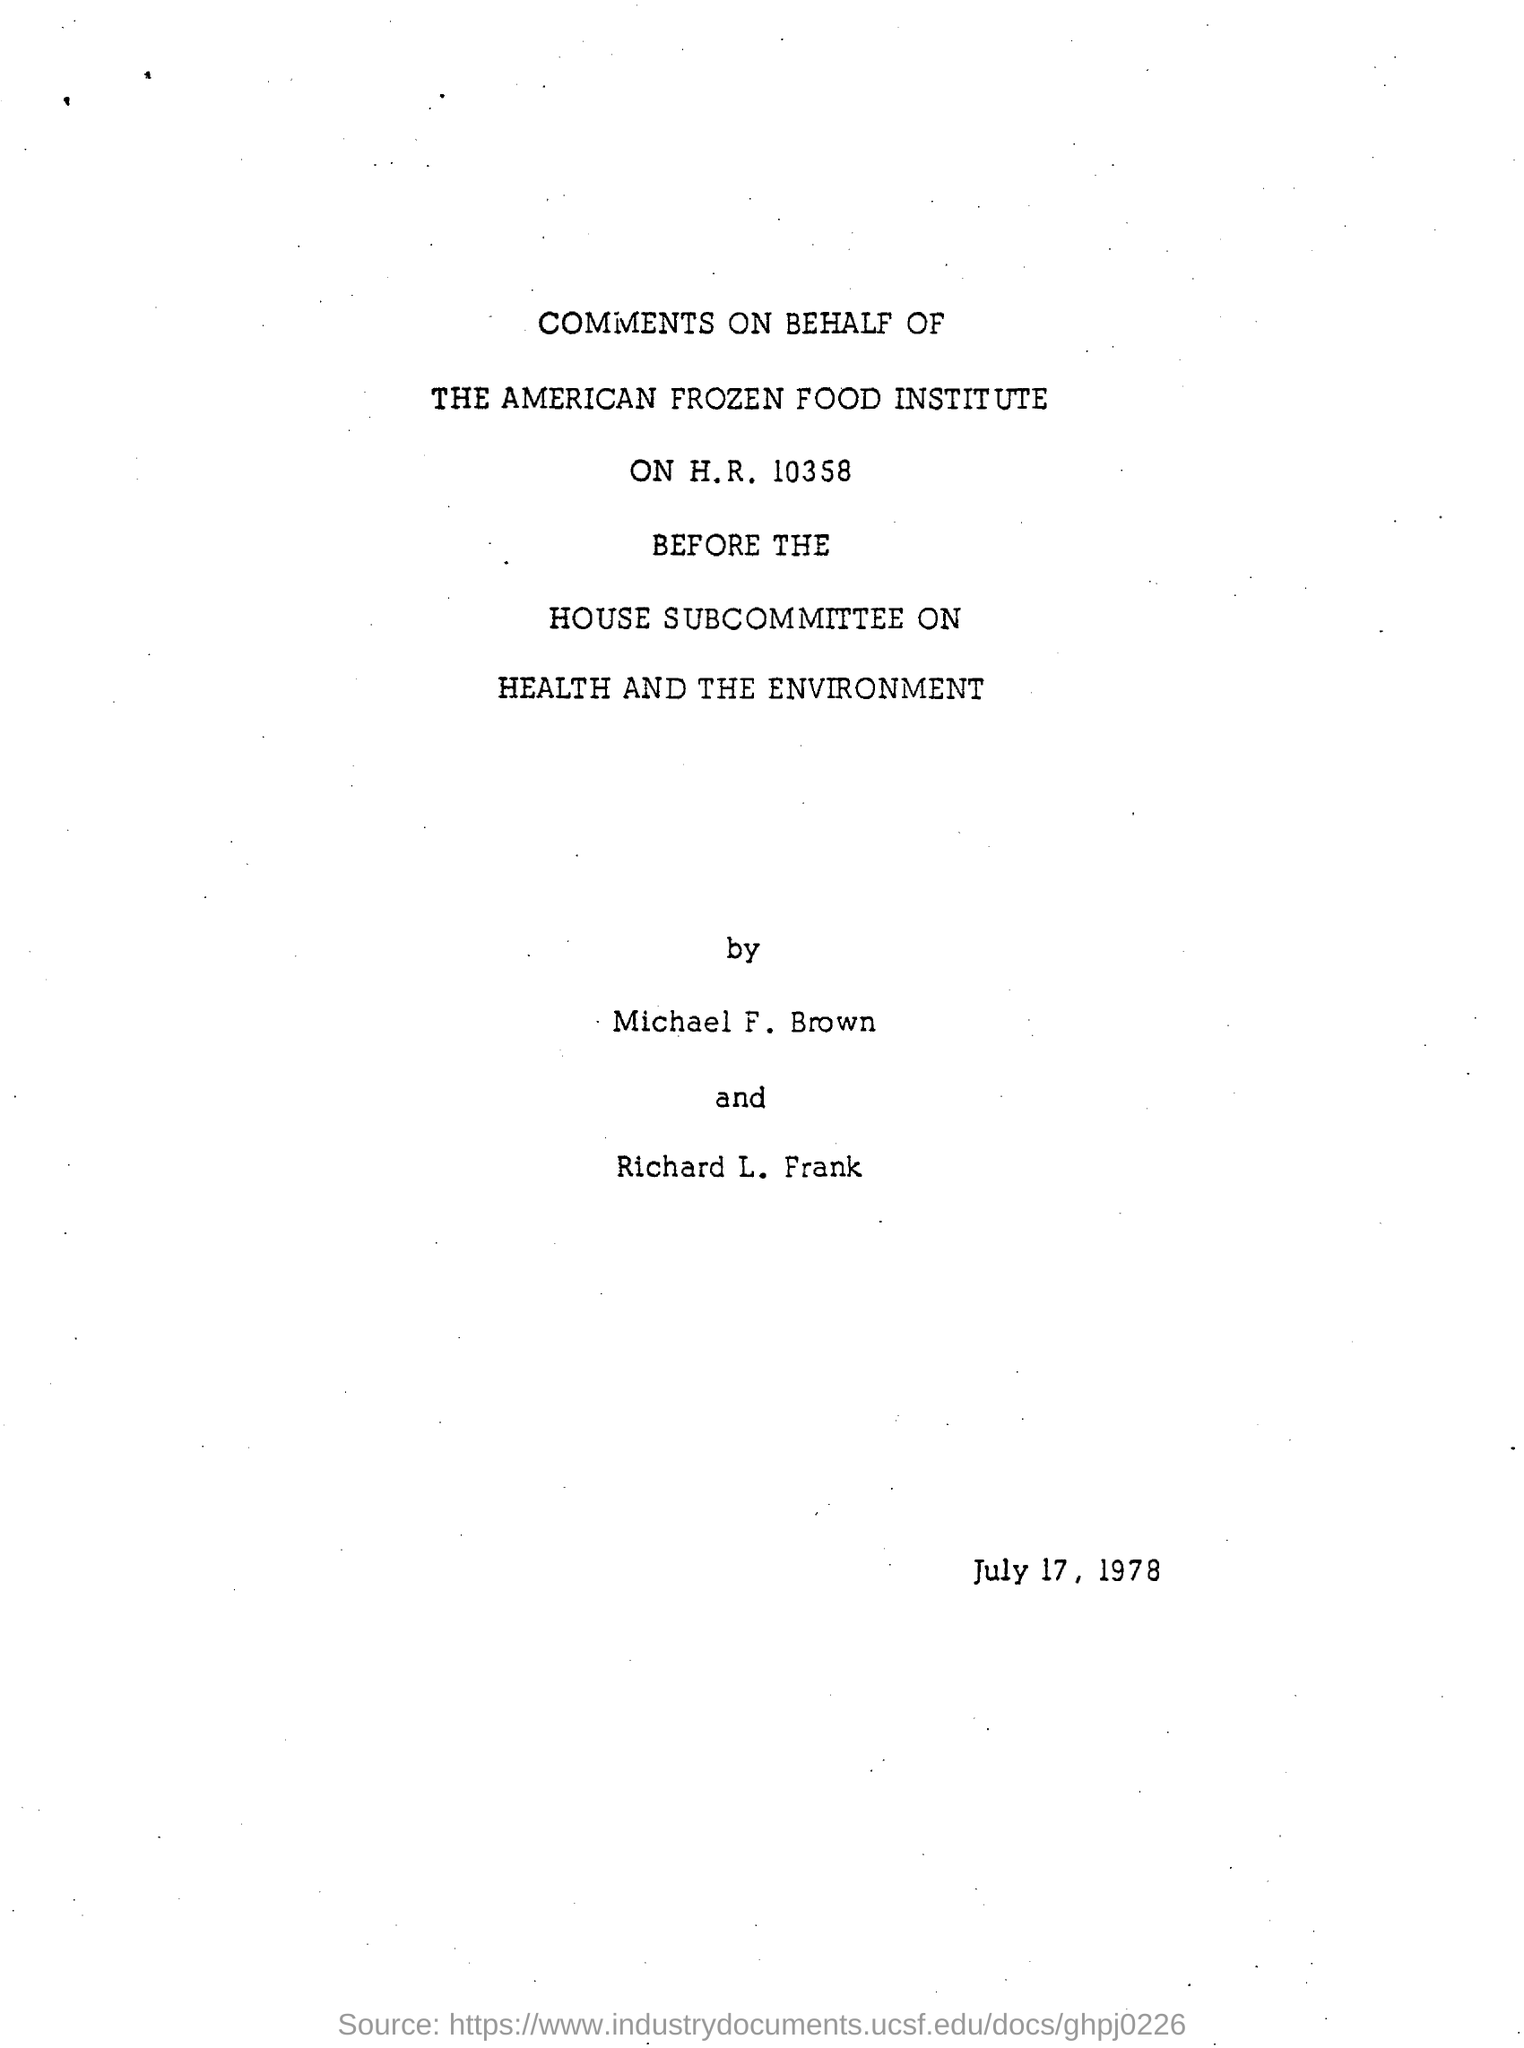List a handful of essential elements in this visual. The American Frozen Food Institute is the name of a food institute. The date mentioned in the document is July 17, 1978. Michael F. Brown and Richard L. Frank have written the comments. 